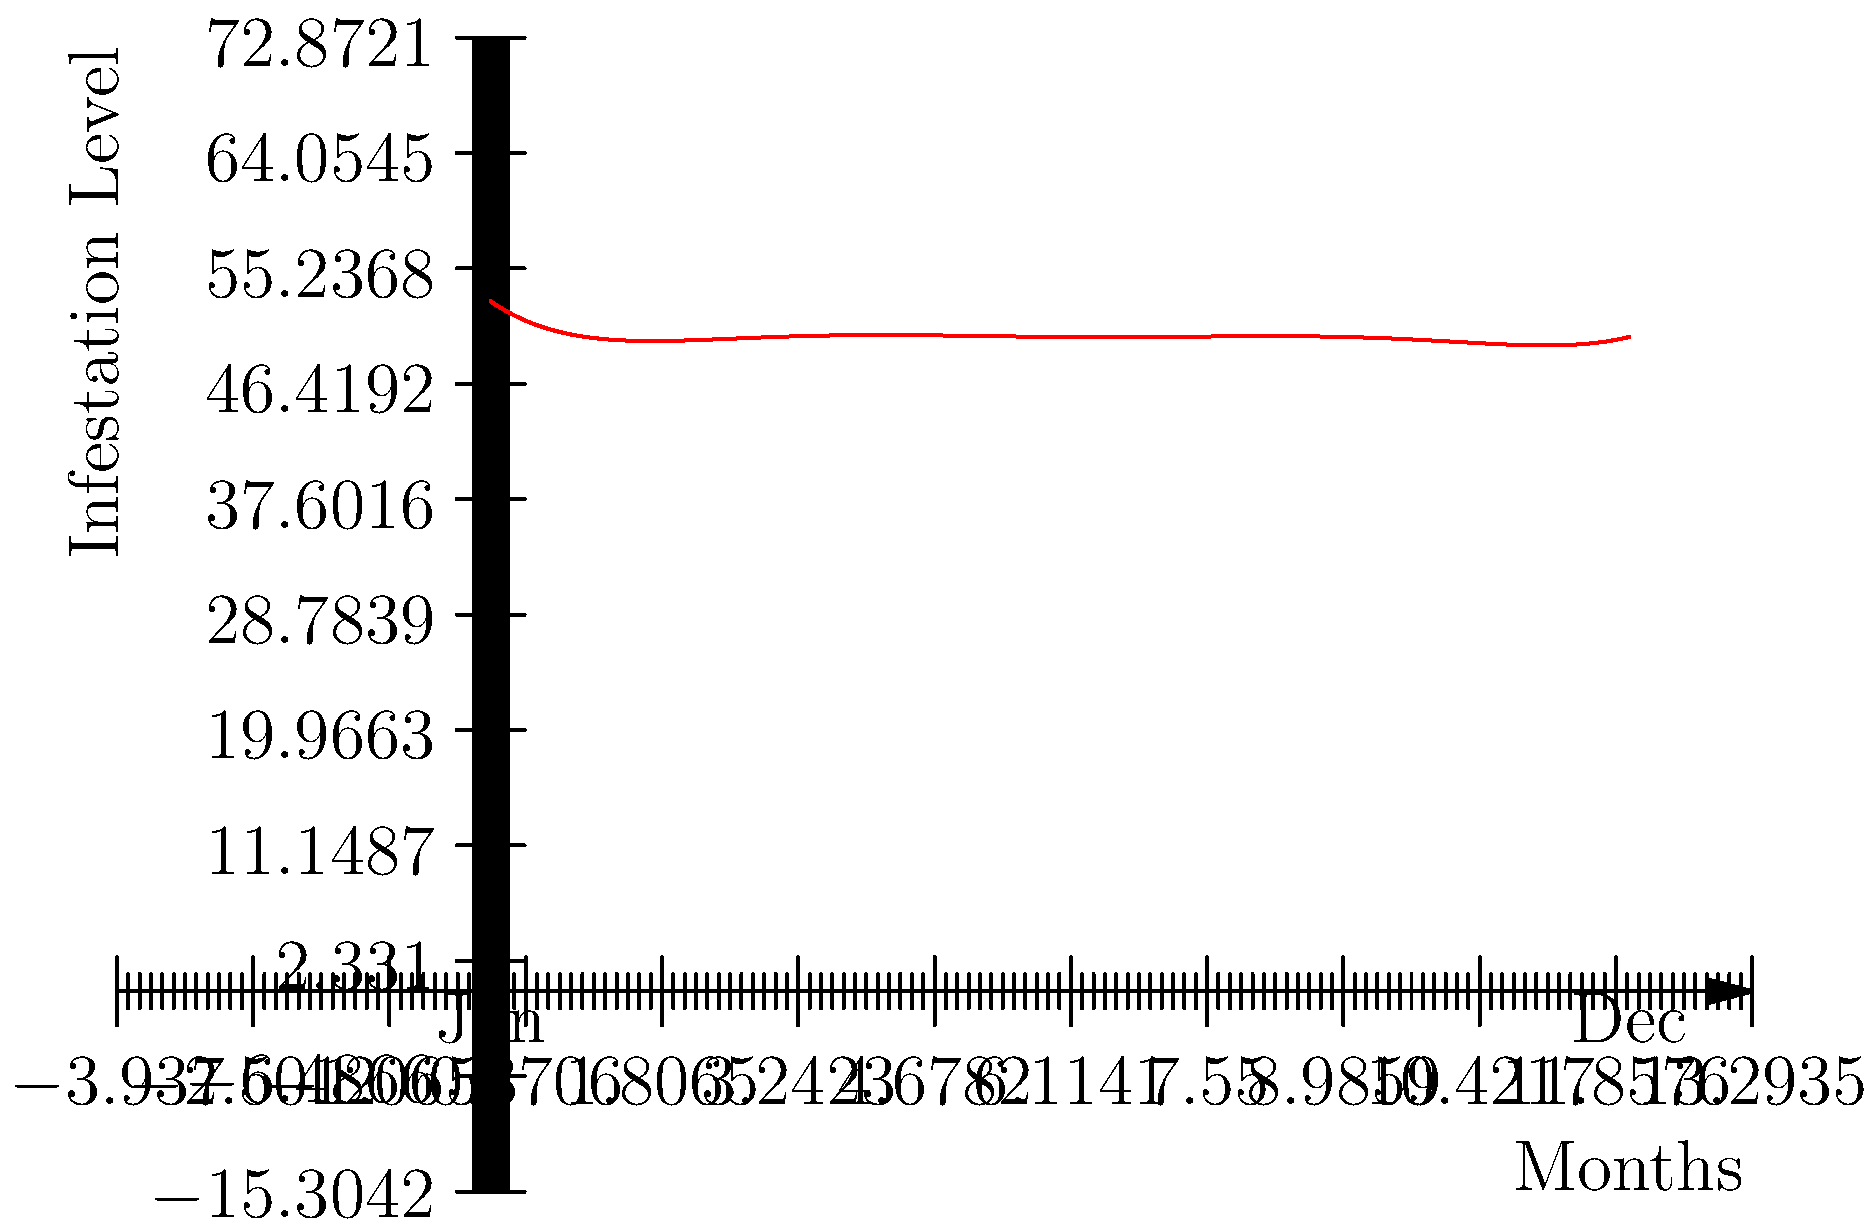Analyze the sixth-degree polynomial graph representing pest infestation levels throughout the year. Which month shows the highest pest activity, and what factors might contribute to this peak? To answer this question, we need to follow these steps:

1. Examine the graph: The x-axis represents months (0 = January, 12 = December), and the y-axis shows infestation levels.

2. Identify the highest point: The graph peaks around the 7-8 month mark, which corresponds to July-August.

3. Consider seasonal factors:
   - Summer months (July-August) typically have warmer temperatures and higher humidity.
   - These conditions are ideal for many pest species to reproduce and thrive.
   - Food sources are often more abundant during summer months.
   - Human activities (e.g., outdoor dining, open windows) may increase pest encounters.

4. Analyze surrounding data:
   - The graph shows lower infestation levels in winter and early spring.
   - There's a gradual increase leading up to the summer peak.
   - After the peak, there's a decline towards fall and winter.

5. Professional insight:
   - Pest control companies often see increased demand during summer months.
   - Preventive measures are crucial in spring to mitigate summer infestations.

The highest pest activity occurs in July-August due to optimal weather conditions for pest reproduction and survival, increased food availability, and human behaviors that may inadvertently attract pests.
Answer: July-August; warm temperatures, high humidity, abundant food sources, and increased human outdoor activities. 